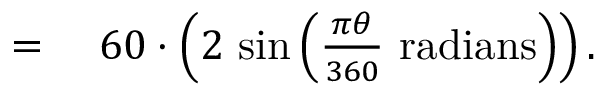<formula> <loc_0><loc_0><loc_500><loc_500>\begin{array} { r l } { } & 6 0 \cdot \left ( 2 \, \sin \left ( { \frac { \pi \theta } { 3 6 0 } } { r a d i a n s } \right ) \right ) . } \end{array}</formula> 